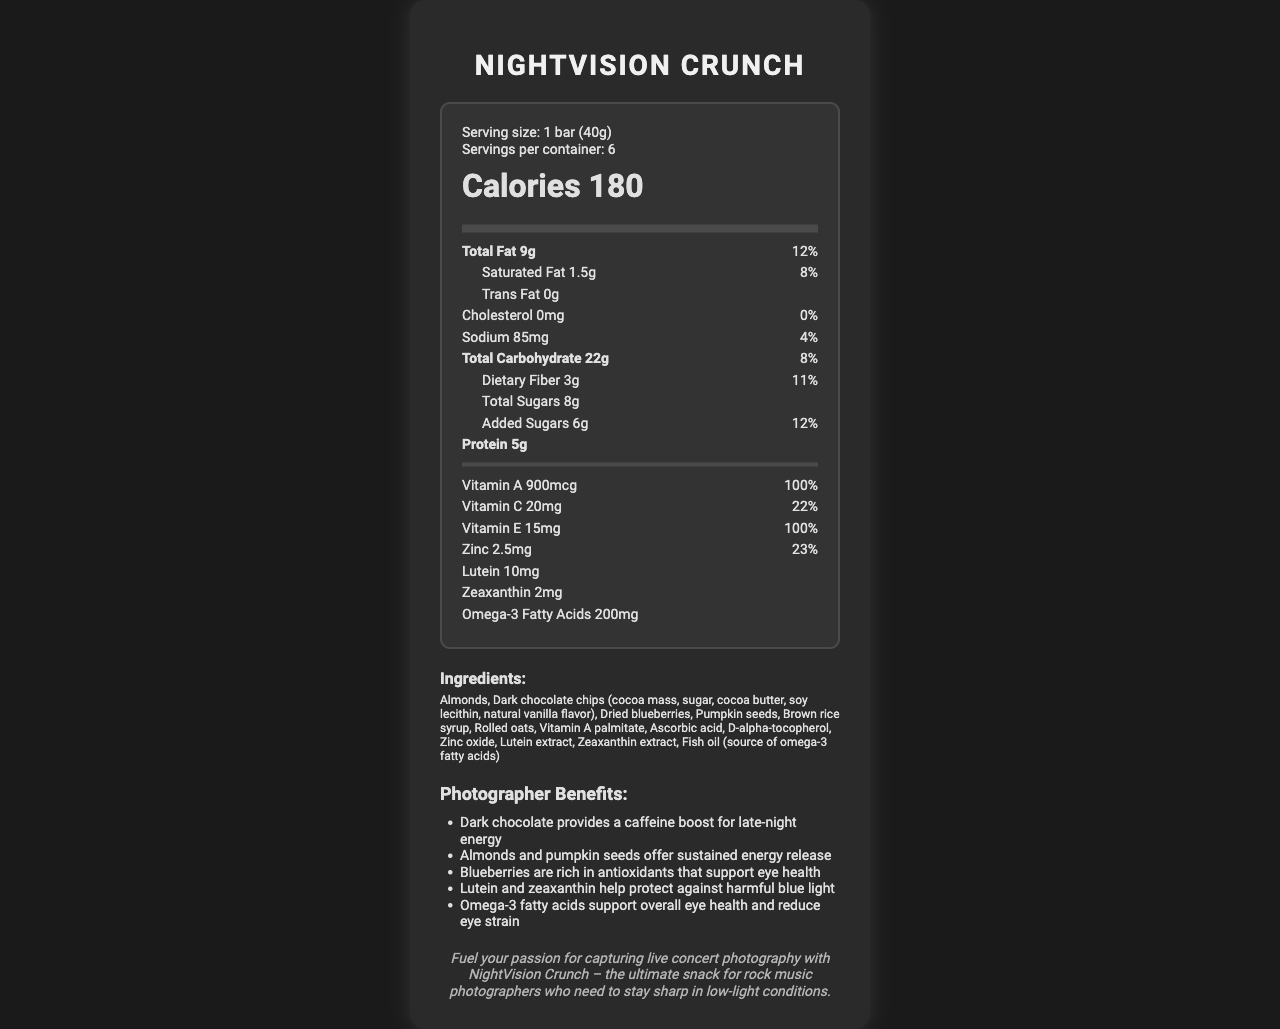what is the serving size of NightVision Crunch? The serving size is listed in the serving information section.
Answer: 1 bar (40g) how many calories are there per serving? The number of calories per serving is displayed prominently in the nutrition label section under the calorie count.
Answer: 180 what is the total fat content in one serving? The total fat content is mentioned in the nutrient section as 9g.
Answer: 9g what percentage of the daily value for Vitamin A does one serving provide? The daily value percentage for Vitamin A is listed as 100% in the vitamins section.
Answer: 100% what ingredients in NightVision Crunch contain omega-3 fatty acids? The list of ingredients includes fish oil, which is identified as the source of omega-3 fatty acids.
Answer: Fish oil what is the primary benefit of lutein and zeaxanthin for photographers? A. Provides a caffeine boost B. Offers sustained energy release C. Helps protect against harmful blue light The photographer benefits section mentions that lutein and zeaxanthin help protect against harmful blue light.
Answer: C how many servings are in each container? A. 4 B. 6 C. 8 D. 10 The serving information section states that there are 6 servings per container.
Answer: B what is the amount of saturated fat in one serving? A. 0g B. 0.5g C. 1.5g D. 2g The amount of saturated fat is listed as 1.5g in the nutrient section.
Answer: C is NightVision Crunch suitable for someone allergic to almonds? (Yes/No) The allergen information section indicates that the product contains almonds.
Answer: No describe the main idea of the document. The document provides comprehensive information about the NightVision Crunch product, including nutritional facts, ingredients, and benefits, particularly focusing on eye health and sustained energy, making it ideal for night photographers.
Answer: NightVision Crunch is a specially formulated snack bar designed for night photographers. It supports eye health and provides energy for late-night shoots. The nutrition label includes essential vitamins and minerals, ingredients, allergen information, and benefits for photographers. what is the manufacturer of NightVision Crunch? The manufacturer's name is mentioned towards the end of the document.
Answer: RockShot Nutrition, Inc. how much zinc is in one serving? The amount of zinc per serving is shown in the vitamins section as 2.5mg.
Answer: 2.5mg what antioxidants in NightVision Crunch support eye health? The benefits section states that blueberries contain antioxidants that support eye health.
Answer: Blueberries can this product be stored at room temperature? The storage instructions recommend storing the product in a cool, dry place, which implies room temperature is acceptable.
Answer: Yes what kind of energy release do almonds and pumpkin seeds offer? The benefits section highlights that almonds and pumpkin seeds offer sustained energy release.
Answer: Sustained energy release what is the connection between NightVision Crunch and rock music photographers? The rock music connection section explicitly mentions the snack's suitability for rock music photographers in low-light situations.
Answer: NightVision Crunch is promoted as an ideal snack for rock music photographers who need to stay sharp in low-light conditions. how much sodium is in one serving? The amount of sodium per serving is detailed as 85mg in the nutrient section.
Answer: 85mg how long should NightVision Crunch be consumed after opening for best freshness? The storage instructions advise consuming the product within 2 weeks of opening for best freshness.
Answer: 2 weeks what other tree nuts might be present in NightVision Crunch? While the allergen information indicates the possibility of tree nuts, it does not specify which ones, so specific tree nuts cannot be determined.
Answer: Cannot be determined 